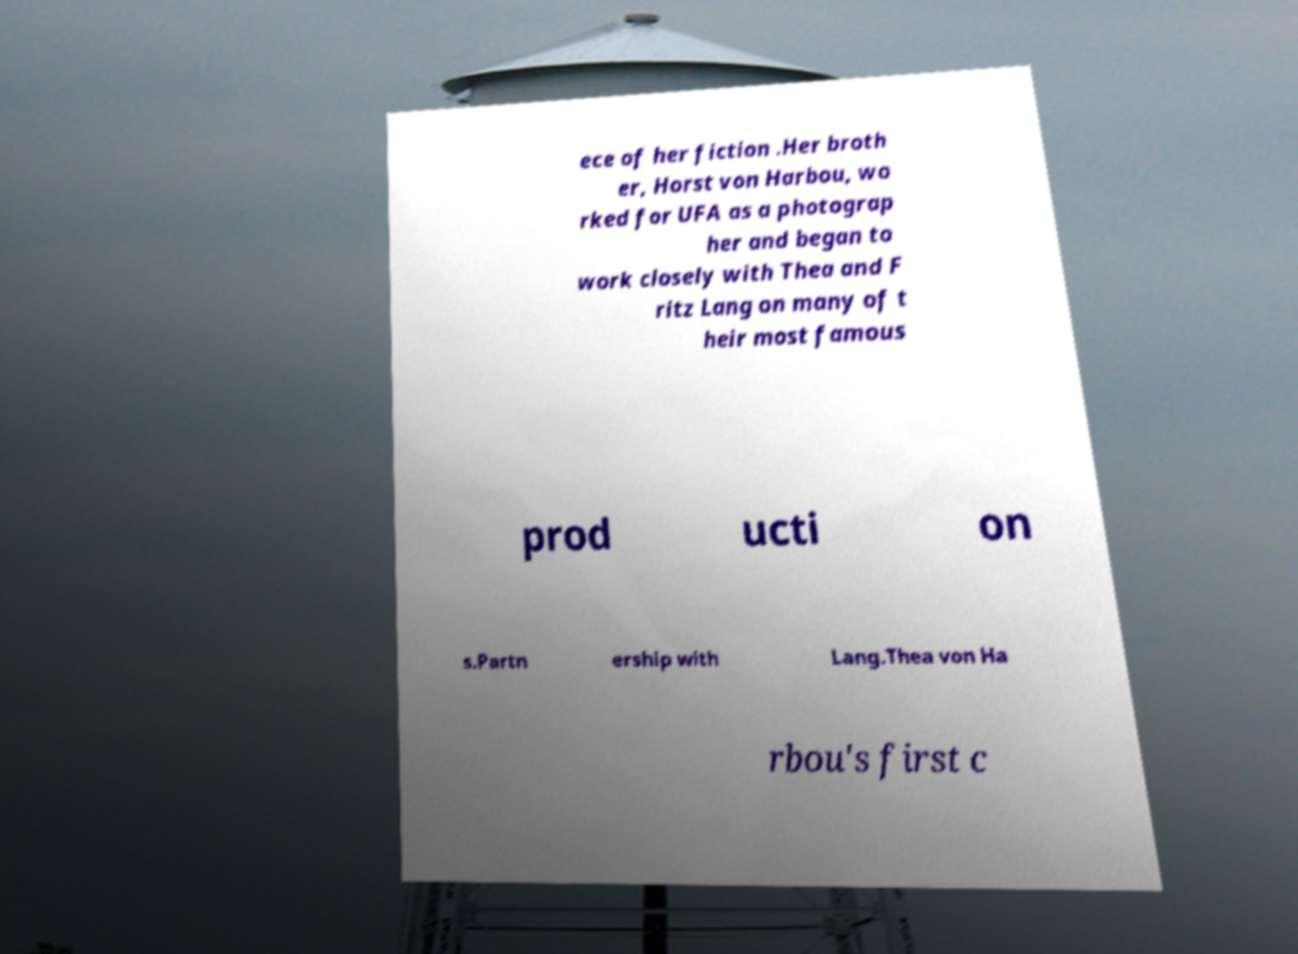There's text embedded in this image that I need extracted. Can you transcribe it verbatim? ece of her fiction .Her broth er, Horst von Harbou, wo rked for UFA as a photograp her and began to work closely with Thea and F ritz Lang on many of t heir most famous prod ucti on s.Partn ership with Lang.Thea von Ha rbou's first c 